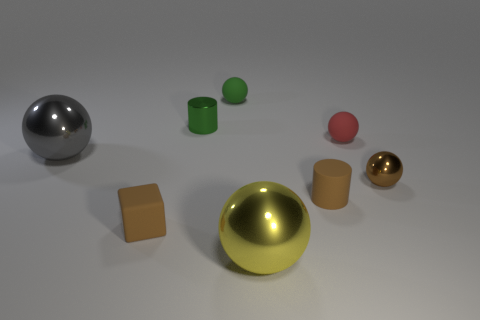Subtract 3 spheres. How many spheres are left? 2 Subtract all brown balls. How many balls are left? 4 Subtract all small brown metallic balls. How many balls are left? 4 Add 2 cylinders. How many objects exist? 10 Subtract all gray balls. Subtract all gray cylinders. How many balls are left? 4 Subtract all balls. How many objects are left? 3 Add 6 tiny brown cylinders. How many tiny brown cylinders exist? 7 Subtract 0 blue balls. How many objects are left? 8 Subtract all cyan rubber cubes. Subtract all big metal balls. How many objects are left? 6 Add 1 tiny red balls. How many tiny red balls are left? 2 